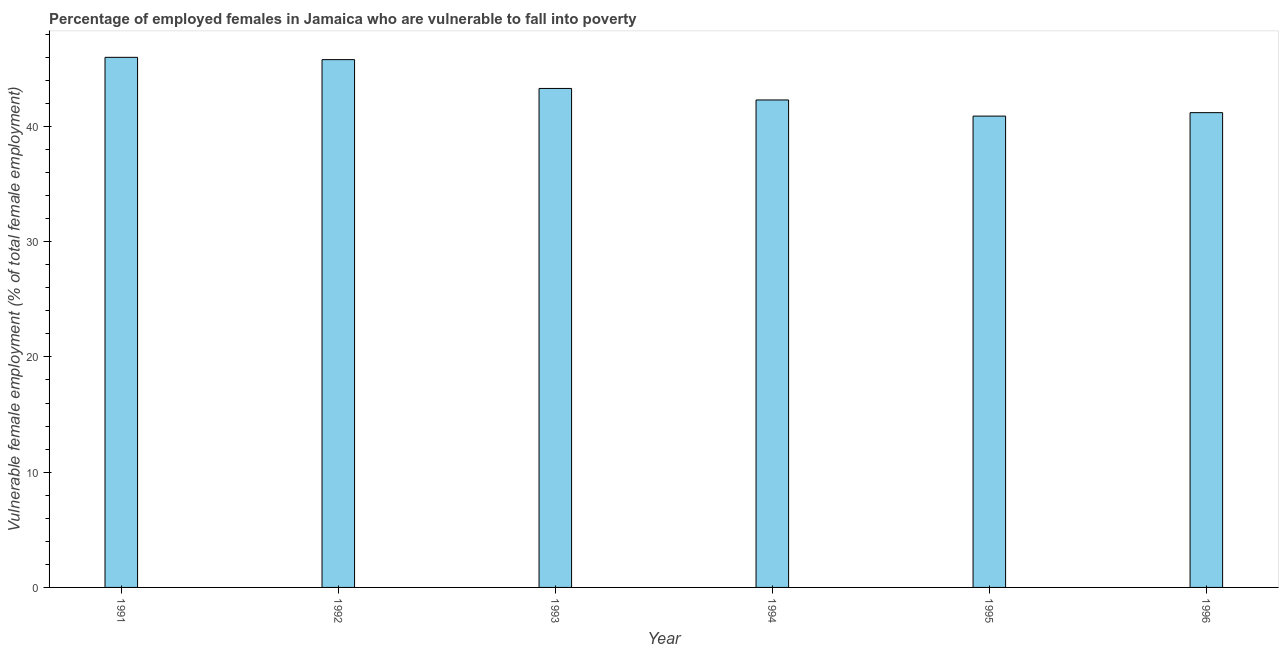Does the graph contain grids?
Offer a very short reply. No. What is the title of the graph?
Give a very brief answer. Percentage of employed females in Jamaica who are vulnerable to fall into poverty. What is the label or title of the Y-axis?
Your answer should be very brief. Vulnerable female employment (% of total female employment). What is the percentage of employed females who are vulnerable to fall into poverty in 1995?
Ensure brevity in your answer.  40.9. Across all years, what is the minimum percentage of employed females who are vulnerable to fall into poverty?
Ensure brevity in your answer.  40.9. In which year was the percentage of employed females who are vulnerable to fall into poverty maximum?
Provide a short and direct response. 1991. In which year was the percentage of employed females who are vulnerable to fall into poverty minimum?
Your answer should be compact. 1995. What is the sum of the percentage of employed females who are vulnerable to fall into poverty?
Provide a short and direct response. 259.5. What is the difference between the percentage of employed females who are vulnerable to fall into poverty in 1992 and 1996?
Offer a terse response. 4.6. What is the average percentage of employed females who are vulnerable to fall into poverty per year?
Offer a terse response. 43.25. What is the median percentage of employed females who are vulnerable to fall into poverty?
Ensure brevity in your answer.  42.8. Do a majority of the years between 1991 and 1995 (inclusive) have percentage of employed females who are vulnerable to fall into poverty greater than 22 %?
Your answer should be compact. Yes. What is the ratio of the percentage of employed females who are vulnerable to fall into poverty in 1991 to that in 1993?
Your answer should be very brief. 1.06. Is the sum of the percentage of employed females who are vulnerable to fall into poverty in 1993 and 1996 greater than the maximum percentage of employed females who are vulnerable to fall into poverty across all years?
Your answer should be very brief. Yes. Are all the bars in the graph horizontal?
Offer a very short reply. No. How many years are there in the graph?
Make the answer very short. 6. What is the difference between two consecutive major ticks on the Y-axis?
Your response must be concise. 10. Are the values on the major ticks of Y-axis written in scientific E-notation?
Your answer should be compact. No. What is the Vulnerable female employment (% of total female employment) of 1992?
Your response must be concise. 45.8. What is the Vulnerable female employment (% of total female employment) in 1993?
Make the answer very short. 43.3. What is the Vulnerable female employment (% of total female employment) of 1994?
Offer a very short reply. 42.3. What is the Vulnerable female employment (% of total female employment) in 1995?
Provide a succinct answer. 40.9. What is the Vulnerable female employment (% of total female employment) of 1996?
Your answer should be compact. 41.2. What is the difference between the Vulnerable female employment (% of total female employment) in 1991 and 1993?
Provide a succinct answer. 2.7. What is the difference between the Vulnerable female employment (% of total female employment) in 1991 and 1995?
Give a very brief answer. 5.1. What is the difference between the Vulnerable female employment (% of total female employment) in 1992 and 1993?
Your answer should be compact. 2.5. What is the difference between the Vulnerable female employment (% of total female employment) in 1992 and 1994?
Your answer should be very brief. 3.5. What is the difference between the Vulnerable female employment (% of total female employment) in 1992 and 1995?
Your answer should be very brief. 4.9. What is the difference between the Vulnerable female employment (% of total female employment) in 1992 and 1996?
Give a very brief answer. 4.6. What is the difference between the Vulnerable female employment (% of total female employment) in 1993 and 1994?
Ensure brevity in your answer.  1. What is the difference between the Vulnerable female employment (% of total female employment) in 1993 and 1995?
Provide a short and direct response. 2.4. What is the difference between the Vulnerable female employment (% of total female employment) in 1994 and 1995?
Offer a very short reply. 1.4. What is the difference between the Vulnerable female employment (% of total female employment) in 1994 and 1996?
Offer a terse response. 1.1. What is the difference between the Vulnerable female employment (% of total female employment) in 1995 and 1996?
Offer a very short reply. -0.3. What is the ratio of the Vulnerable female employment (% of total female employment) in 1991 to that in 1992?
Make the answer very short. 1. What is the ratio of the Vulnerable female employment (% of total female employment) in 1991 to that in 1993?
Your answer should be compact. 1.06. What is the ratio of the Vulnerable female employment (% of total female employment) in 1991 to that in 1994?
Offer a terse response. 1.09. What is the ratio of the Vulnerable female employment (% of total female employment) in 1991 to that in 1995?
Give a very brief answer. 1.12. What is the ratio of the Vulnerable female employment (% of total female employment) in 1991 to that in 1996?
Give a very brief answer. 1.12. What is the ratio of the Vulnerable female employment (% of total female employment) in 1992 to that in 1993?
Your response must be concise. 1.06. What is the ratio of the Vulnerable female employment (% of total female employment) in 1992 to that in 1994?
Give a very brief answer. 1.08. What is the ratio of the Vulnerable female employment (% of total female employment) in 1992 to that in 1995?
Provide a short and direct response. 1.12. What is the ratio of the Vulnerable female employment (% of total female employment) in 1992 to that in 1996?
Keep it short and to the point. 1.11. What is the ratio of the Vulnerable female employment (% of total female employment) in 1993 to that in 1994?
Give a very brief answer. 1.02. What is the ratio of the Vulnerable female employment (% of total female employment) in 1993 to that in 1995?
Ensure brevity in your answer.  1.06. What is the ratio of the Vulnerable female employment (% of total female employment) in 1993 to that in 1996?
Your answer should be very brief. 1.05. What is the ratio of the Vulnerable female employment (% of total female employment) in 1994 to that in 1995?
Your answer should be compact. 1.03. 